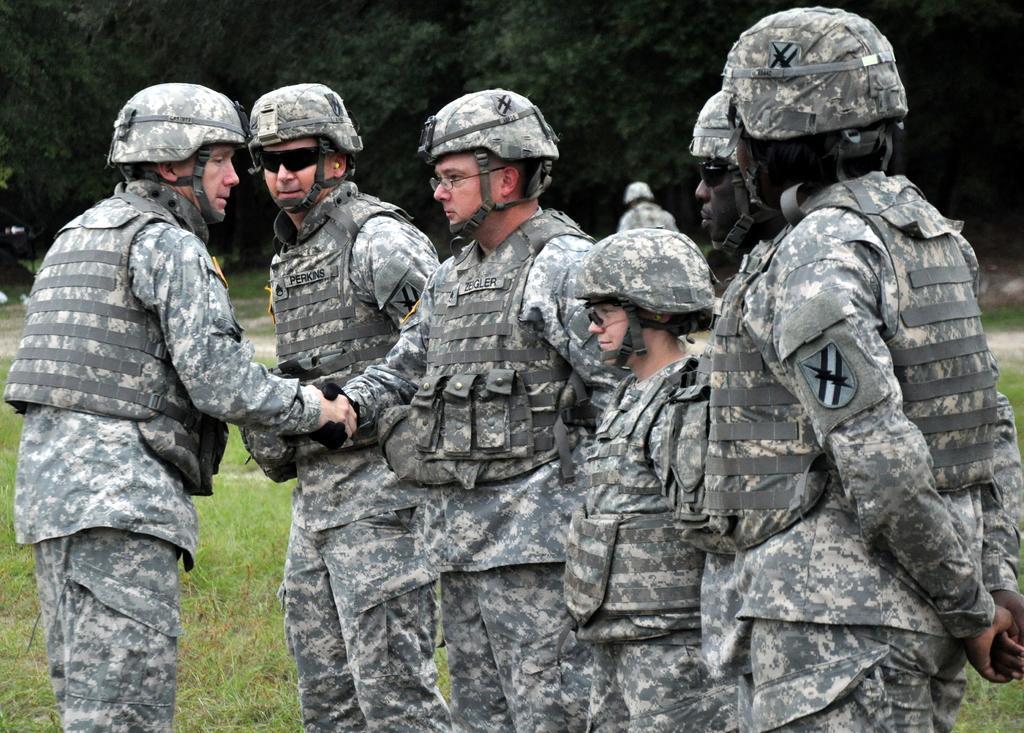Could you give a brief overview of what you see in this image? In the picture we can see six army people are standing on the grass surface and one army man is shaking hand with another army man and they are in uniforms and helmets and behind them we can see one person is walking and in the background we can see full of trees. 